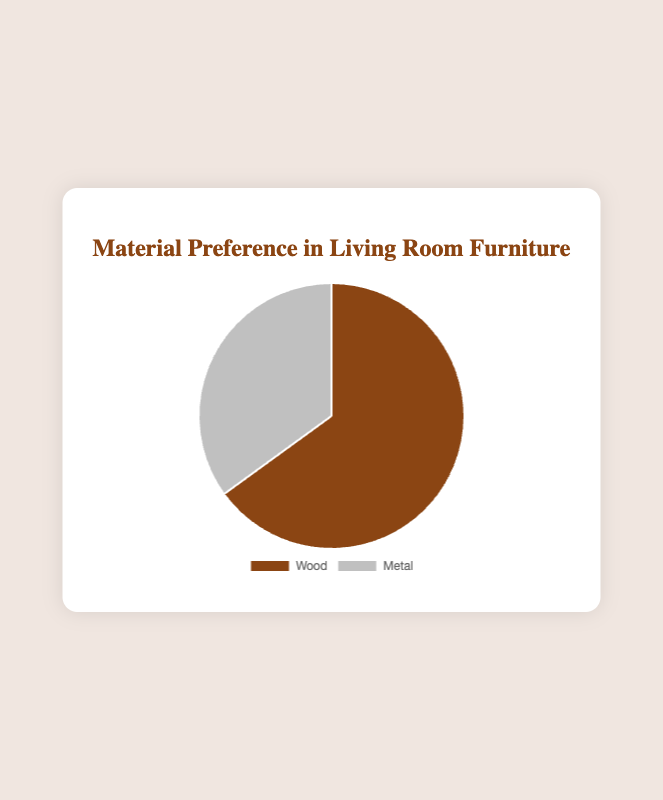What's the title of the chart? The title is placed at the top of the chart in a larger font. It reads "Material Preference in Living Room Furniture".
Answer: Material Preference in Living Room Furniture What are the two materials compared in the chart? The chart has two segments with labels. One is for "Wood" and the other is for "Metal".
Answer: Wood and Metal Which material has a higher percentage preference? By looking at the size of the segments or the labels, "Wood" has a higher percentage preference compared to "Metal".
Answer: Wood What is the percentage preference for Metal? The label for Metal indicates it has a preference percentage of 35%.
Answer: 35% How much more preferred is Wood compared to Metal? The percentage preference for Wood is 65% and for Metal is 35%. The difference is 65% - 35% = 30%.
Answer: 30% What is the combined percentage preference for both materials? Adding the preference percentages for Wood (65%) and Metal (35%) results in: 65% + 35% = 100%.
Answer: 100% What are the colors representing Wood and Metal in the pie chart? The segment for Wood is colored brown and the segment for Metal is colored silver.
Answer: Brown and Silver If another material was added with the same percentage as Metal, what would be the new combined percentage for Metal and the new material? Metal currently has a 35% preference. If another identical segment is added, you would sum the two 35% segments: 35% + 35% = 70%.
Answer: 70% What mathematical operation would you use to find the percentage preference remaining if Wood was not considered? Subtract Wood’s percentage (65%) from the total percentage (100%): 100% - 65% = 35%.
Answer: Subtraction If the preferences changed to 50% for Wood and 50% for Metal, how would the pie chart visually change? The segments in the pie chart would be equal in size, each occupying 50% of the chart.
Answer: Equal sizes 